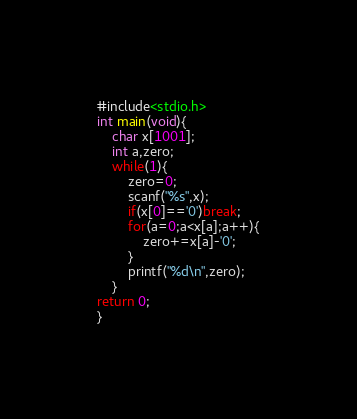<code> <loc_0><loc_0><loc_500><loc_500><_C_>#include<stdio.h>
int main(void){
    char x[1001];
    int a,zero;
    while(1){
        zero=0;
        scanf("%s",x);
        if(x[0]=='0')break;
        for(a=0;a<x[a];a++){
            zero+=x[a]-'0';
        }
        printf("%d\n",zero);
    }
return 0;
}</code> 